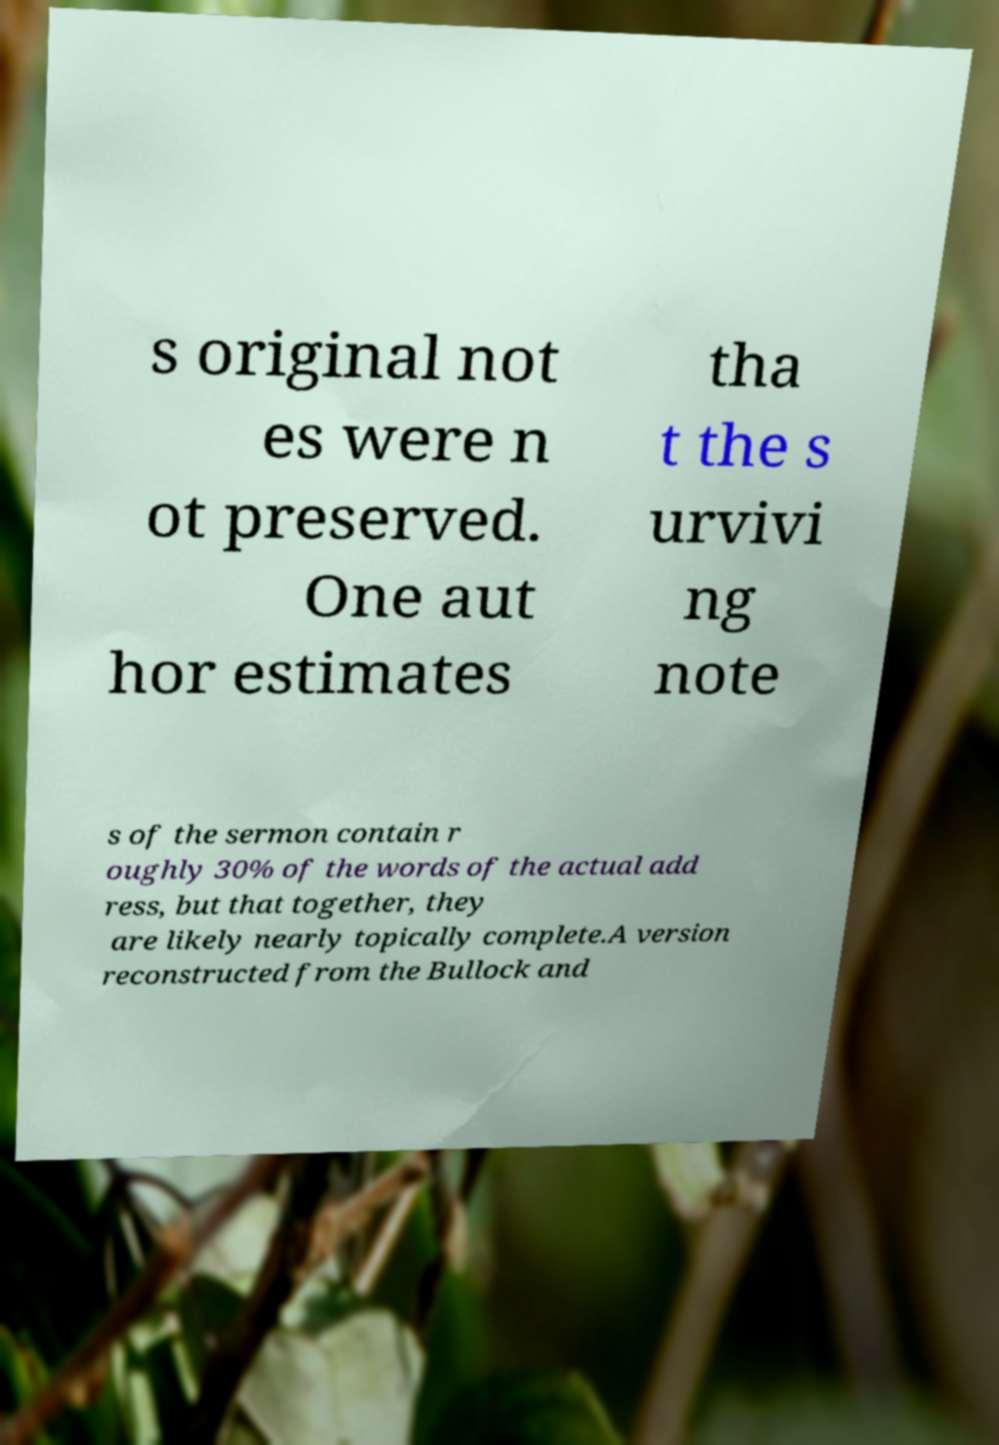Please read and relay the text visible in this image. What does it say? s original not es were n ot preserved. One aut hor estimates tha t the s urvivi ng note s of the sermon contain r oughly 30% of the words of the actual add ress, but that together, they are likely nearly topically complete.A version reconstructed from the Bullock and 